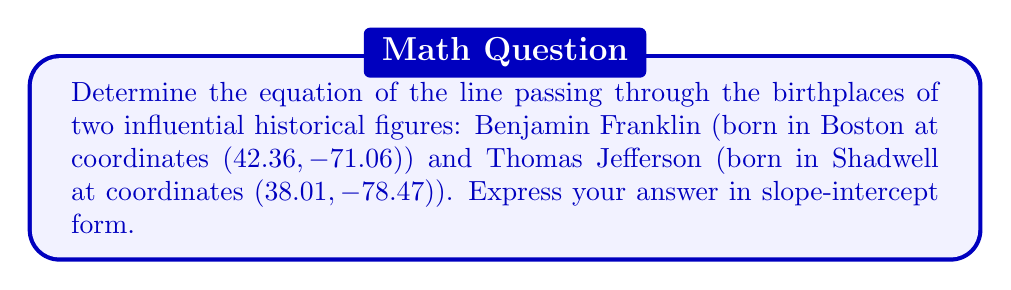Teach me how to tackle this problem. To find the equation of the line passing through two points, we'll use the point-slope form and then convert it to slope-intercept form. Let's approach this step-by-step:

1. Identify the two points:
   Point 1 (Franklin's birthplace): $(x_1, y_1) = (42.36, -71.06)$
   Point 2 (Jefferson's birthplace): $(x_2, y_2) = (38.01, -78.47)$

2. Calculate the slope (m) using the slope formula:
   $$m = \frac{y_2 - y_1}{x_2 - x_1} = \frac{-78.47 - (-71.06)}{38.01 - 42.36} = \frac{-7.41}{-4.35} \approx 1.7034$$

3. Use the point-slope form of a line with Franklin's birthplace $(42.36, -71.06)$:
   $$y - y_1 = m(x - x_1)$$
   $$y - (-71.06) = 1.7034(x - 42.36)$$

4. Distribute the slope:
   $$y + 71.06 = 1.7034x - 72.1561$$

5. Solve for y to get the slope-intercept form $(y = mx + b)$:
   $$y = 1.7034x - 72.1561 - 71.06$$
   $$y = 1.7034x - 143.2161$$

6. Round coefficients to four decimal places:
   $$y = 1.7034x - 143.2161$$

This equation represents the line passing through the birthplaces of Benjamin Franklin and Thomas Jefferson.
Answer: $y = 1.7034x - 143.2161$ 